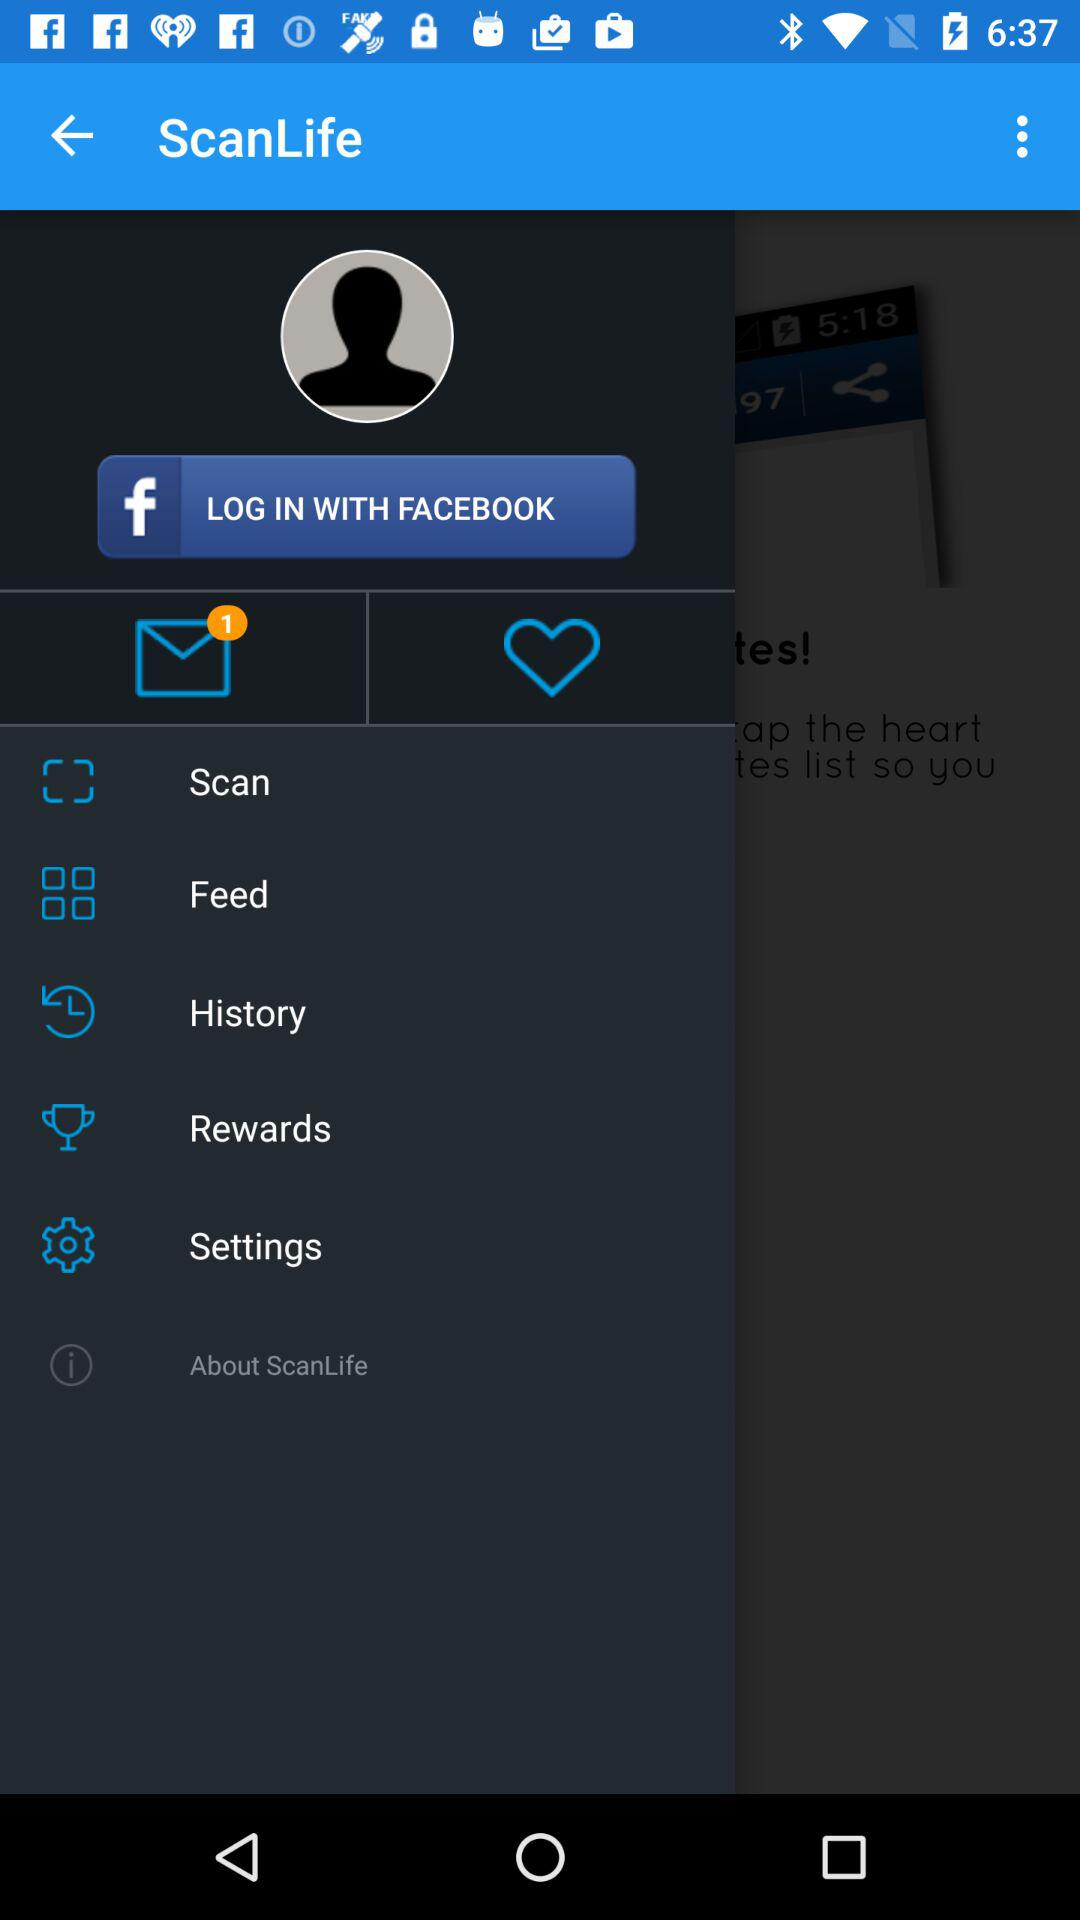What application can be used to log in? The application "FACEBOOK" can be used to log in. 